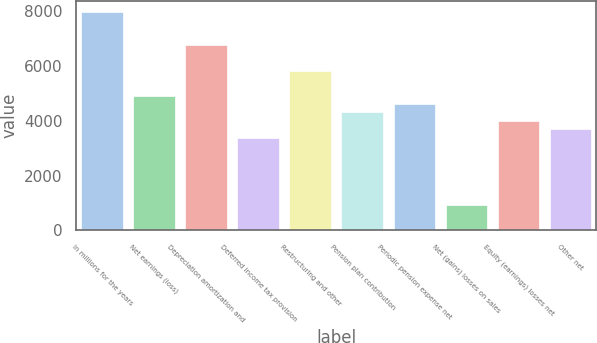<chart> <loc_0><loc_0><loc_500><loc_500><bar_chart><fcel>In millions for the years<fcel>Net earnings (loss)<fcel>Depreciation amortization and<fcel>Deferred income tax provision<fcel>Restructuring and other<fcel>Pension plan contribution<fcel>Periodic pension expense net<fcel>Net (gains) losses on sales<fcel>Equity (earnings) losses net<fcel>Other net<nl><fcel>7971.4<fcel>4912.4<fcel>6747.8<fcel>3382.9<fcel>5830.1<fcel>4300.6<fcel>4606.5<fcel>935.7<fcel>3994.7<fcel>3688.8<nl></chart> 